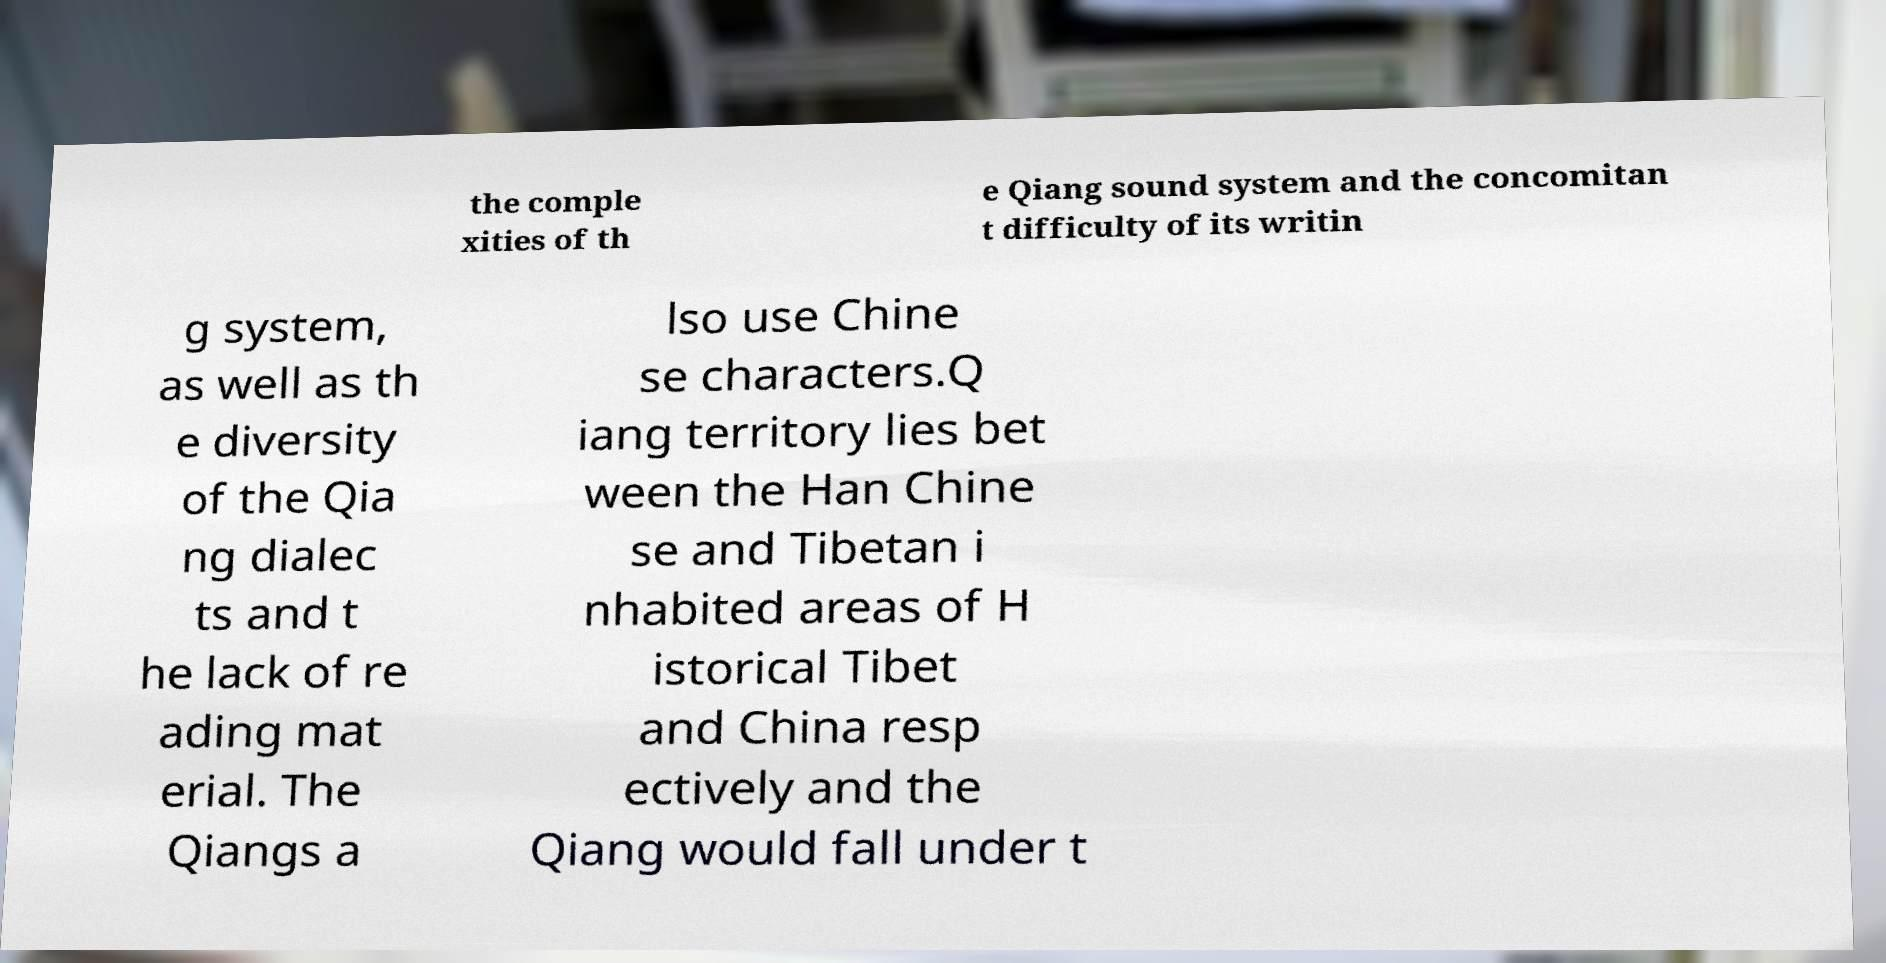Please read and relay the text visible in this image. What does it say? the comple xities of th e Qiang sound system and the concomitan t difficulty of its writin g system, as well as th e diversity of the Qia ng dialec ts and t he lack of re ading mat erial. The Qiangs a lso use Chine se characters.Q iang territory lies bet ween the Han Chine se and Tibetan i nhabited areas of H istorical Tibet and China resp ectively and the Qiang would fall under t 